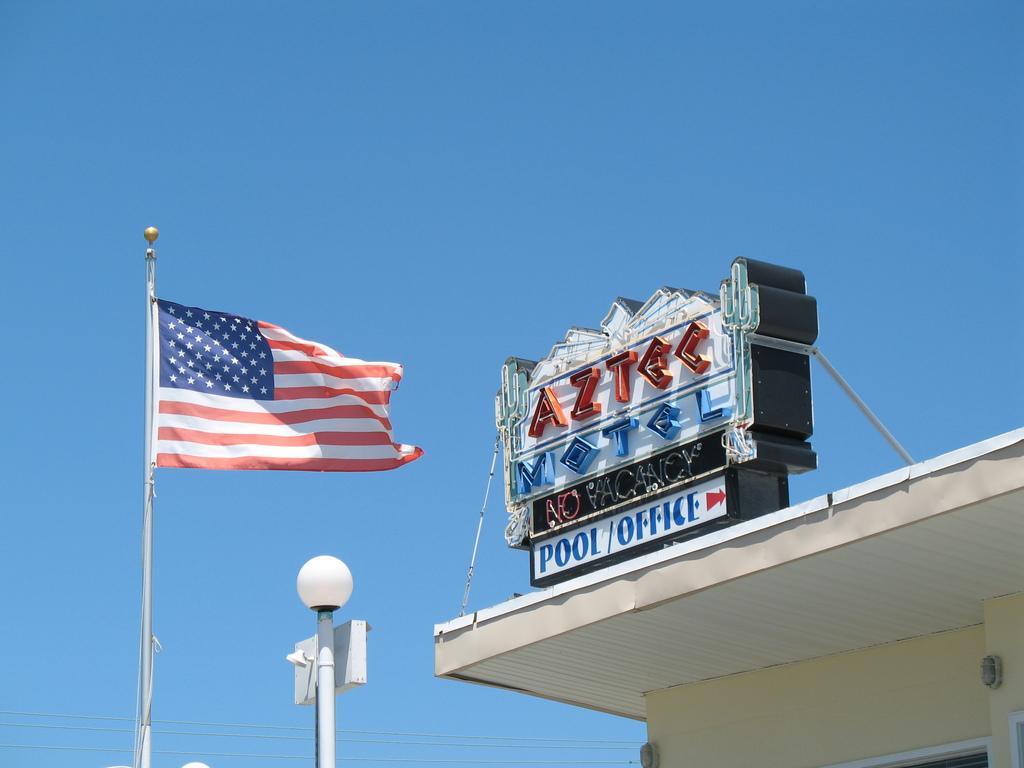Can you describe this image briefly? In this image we can see a name board to a building, a street pole and the flag. On the backside we can see the sky. 